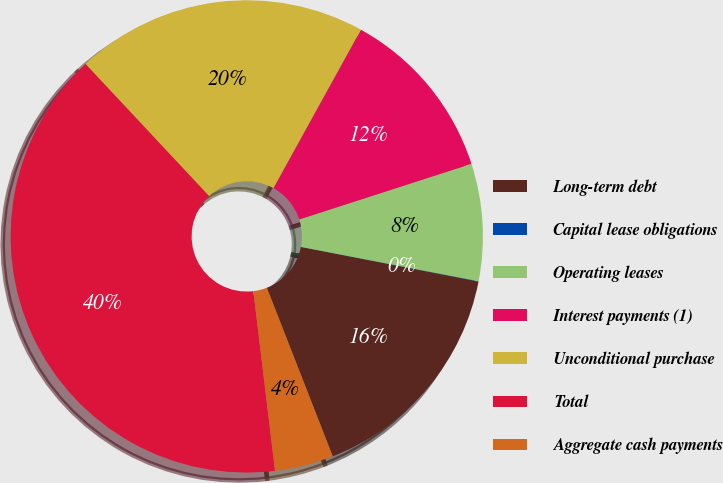Convert chart. <chart><loc_0><loc_0><loc_500><loc_500><pie_chart><fcel>Long-term debt<fcel>Capital lease obligations<fcel>Operating leases<fcel>Interest payments (1)<fcel>Unconditional purchase<fcel>Total<fcel>Aggregate cash payments<nl><fcel>16.0%<fcel>0.03%<fcel>8.01%<fcel>12.0%<fcel>19.99%<fcel>39.94%<fcel>4.02%<nl></chart> 